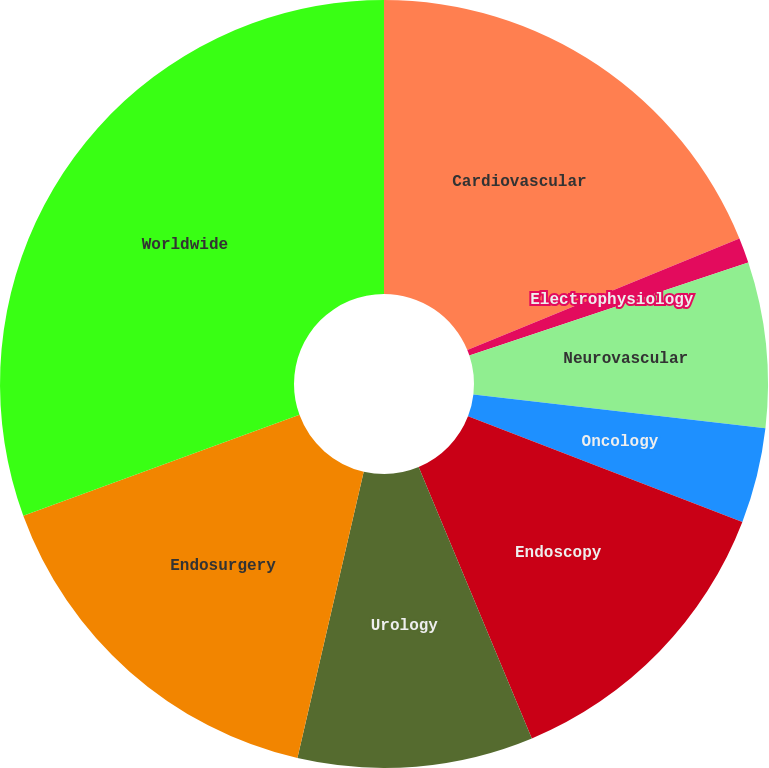Convert chart to OTSL. <chart><loc_0><loc_0><loc_500><loc_500><pie_chart><fcel>Cardiovascular<fcel>Electrophysiology<fcel>Neurovascular<fcel>Oncology<fcel>Endoscopy<fcel>Urology<fcel>Endosurgery<fcel>Worldwide<nl><fcel>18.82%<fcel>1.06%<fcel>6.96%<fcel>4.01%<fcel>12.86%<fcel>9.91%<fcel>15.81%<fcel>30.57%<nl></chart> 